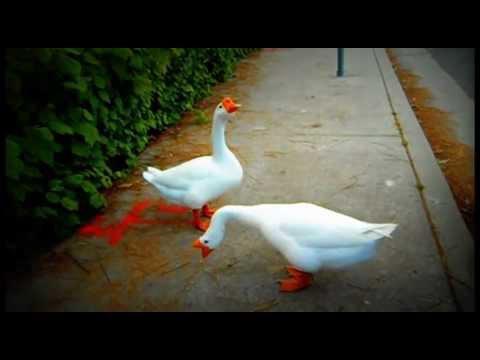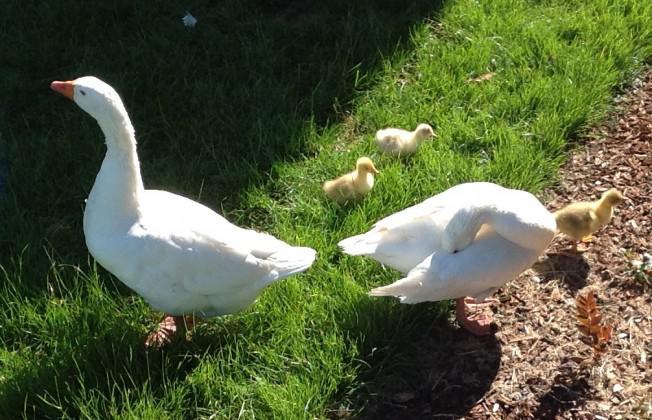The first image is the image on the left, the second image is the image on the right. For the images displayed, is the sentence "All ducks shown are white, and no image includes fuzzy ducklings." factually correct? Answer yes or no. No. The first image is the image on the left, the second image is the image on the right. Analyze the images presented: Is the assertion "The left image contains exactly two white ducks." valid? Answer yes or no. Yes. 